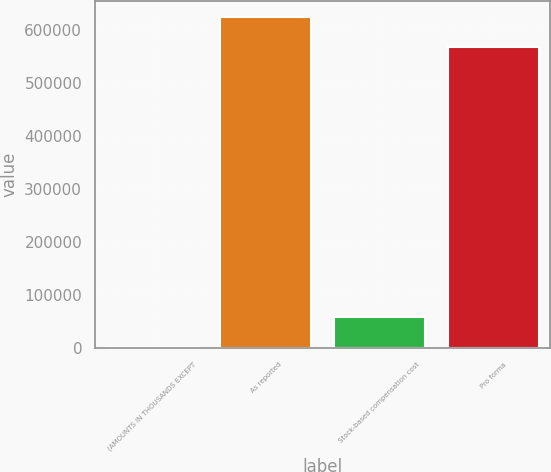Convert chart to OTSL. <chart><loc_0><loc_0><loc_500><loc_500><bar_chart><fcel>(AMOUNTS IN THOUSANDS EXCEPT<fcel>As reported<fcel>Stock-based compensation cost<fcel>Pro forma<nl><fcel>2004<fcel>623944<fcel>58903.3<fcel>567045<nl></chart> 